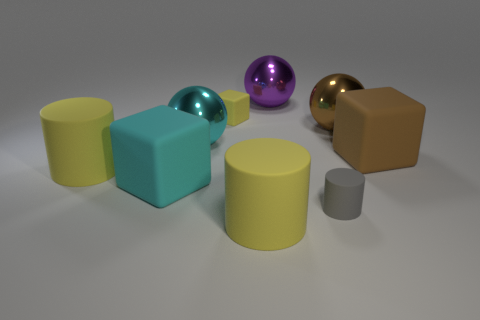How many blue objects are either cubes or big spheres?
Provide a short and direct response. 0. What number of other objects are there of the same shape as the big purple object?
Offer a very short reply. 2. Does the ball on the left side of the small yellow matte thing have the same color as the rubber cube that is behind the brown block?
Ensure brevity in your answer.  No. What number of large things are matte cylinders or blocks?
Ensure brevity in your answer.  4. There is a brown shiny object that is the same shape as the big purple metallic thing; what size is it?
Your response must be concise. Large. Is there anything else that has the same size as the purple thing?
Make the answer very short. Yes. What material is the large cyan thing that is in front of the large yellow thing to the left of the small yellow thing?
Your response must be concise. Rubber. What number of rubber objects are either small red cylinders or big things?
Make the answer very short. 4. There is another big rubber thing that is the same shape as the big cyan rubber thing; what is its color?
Ensure brevity in your answer.  Brown. How many rubber things are the same color as the tiny rubber cube?
Your response must be concise. 2. 